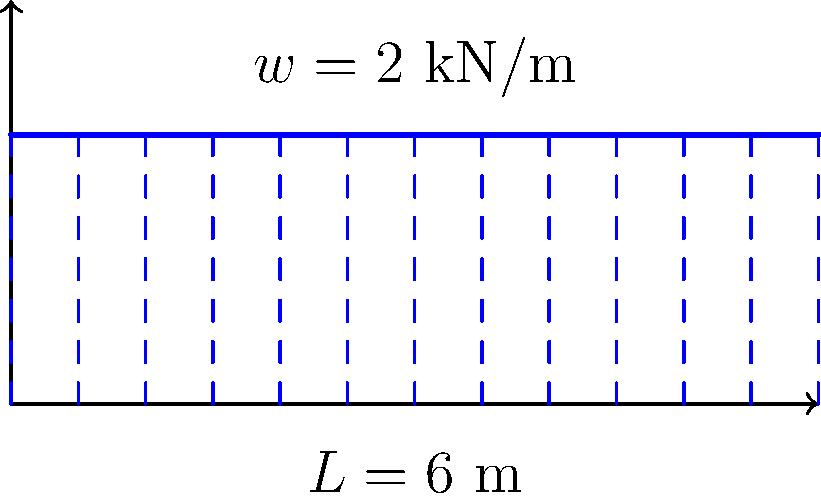In honor of Chris Townsend's adventurous spirit, imagine a bridge beam spanning a mountain gorge. The beam is 6 meters long and subjected to a uniformly distributed load of 2 kN/m along its entire length. Calculate the maximum bending moment in the beam, assuming it is simply supported at both ends. Let's approach this step-by-step, imagining we're designing a sturdy bridge for one of Chris Townsend's expeditions:

1) First, we identify the given information:
   - Beam length, $L = 6$ m
   - Uniformly distributed load, $w = 2$ kN/m

2) For a simply supported beam with a uniformly distributed load, the maximum bending moment occurs at the middle of the beam and is given by the formula:

   $M_{max} = \frac{wL^2}{8}$

3) Now, let's substitute our values:
   
   $M_{max} = \frac{2 \text{ kN/m} \times (6 \text{ m})^2}{8}$

4) Let's calculate:
   
   $M_{max} = \frac{2 \times 36}{8} = \frac{72}{8} = 9 \text{ kN}\cdot\text{m}$

5) Therefore, the maximum bending moment in the beam is 9 kN·m.

This result ensures that our hypothetical bridge beam can withstand the forces it might encounter, allowing adventurers like Chris Townsend to safely cross challenging terrains.
Answer: 9 kN·m 